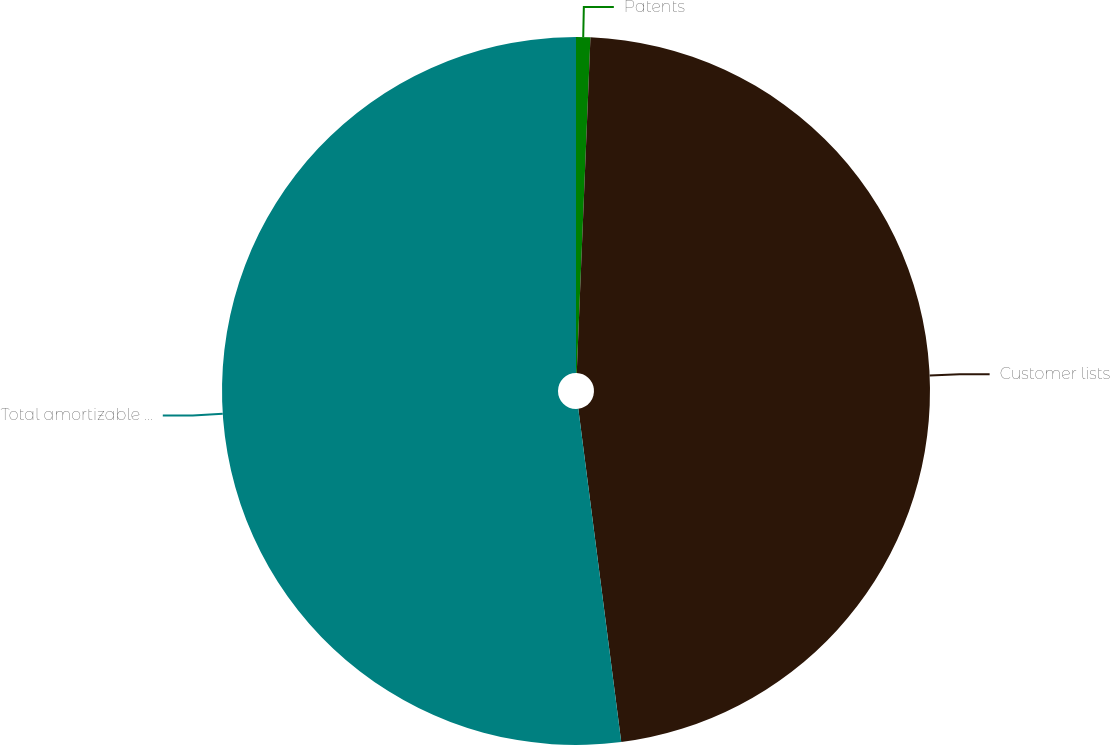<chart> <loc_0><loc_0><loc_500><loc_500><pie_chart><fcel>Patents<fcel>Customer lists<fcel>Total amortizable intangible<nl><fcel>0.65%<fcel>47.31%<fcel>52.04%<nl></chart> 